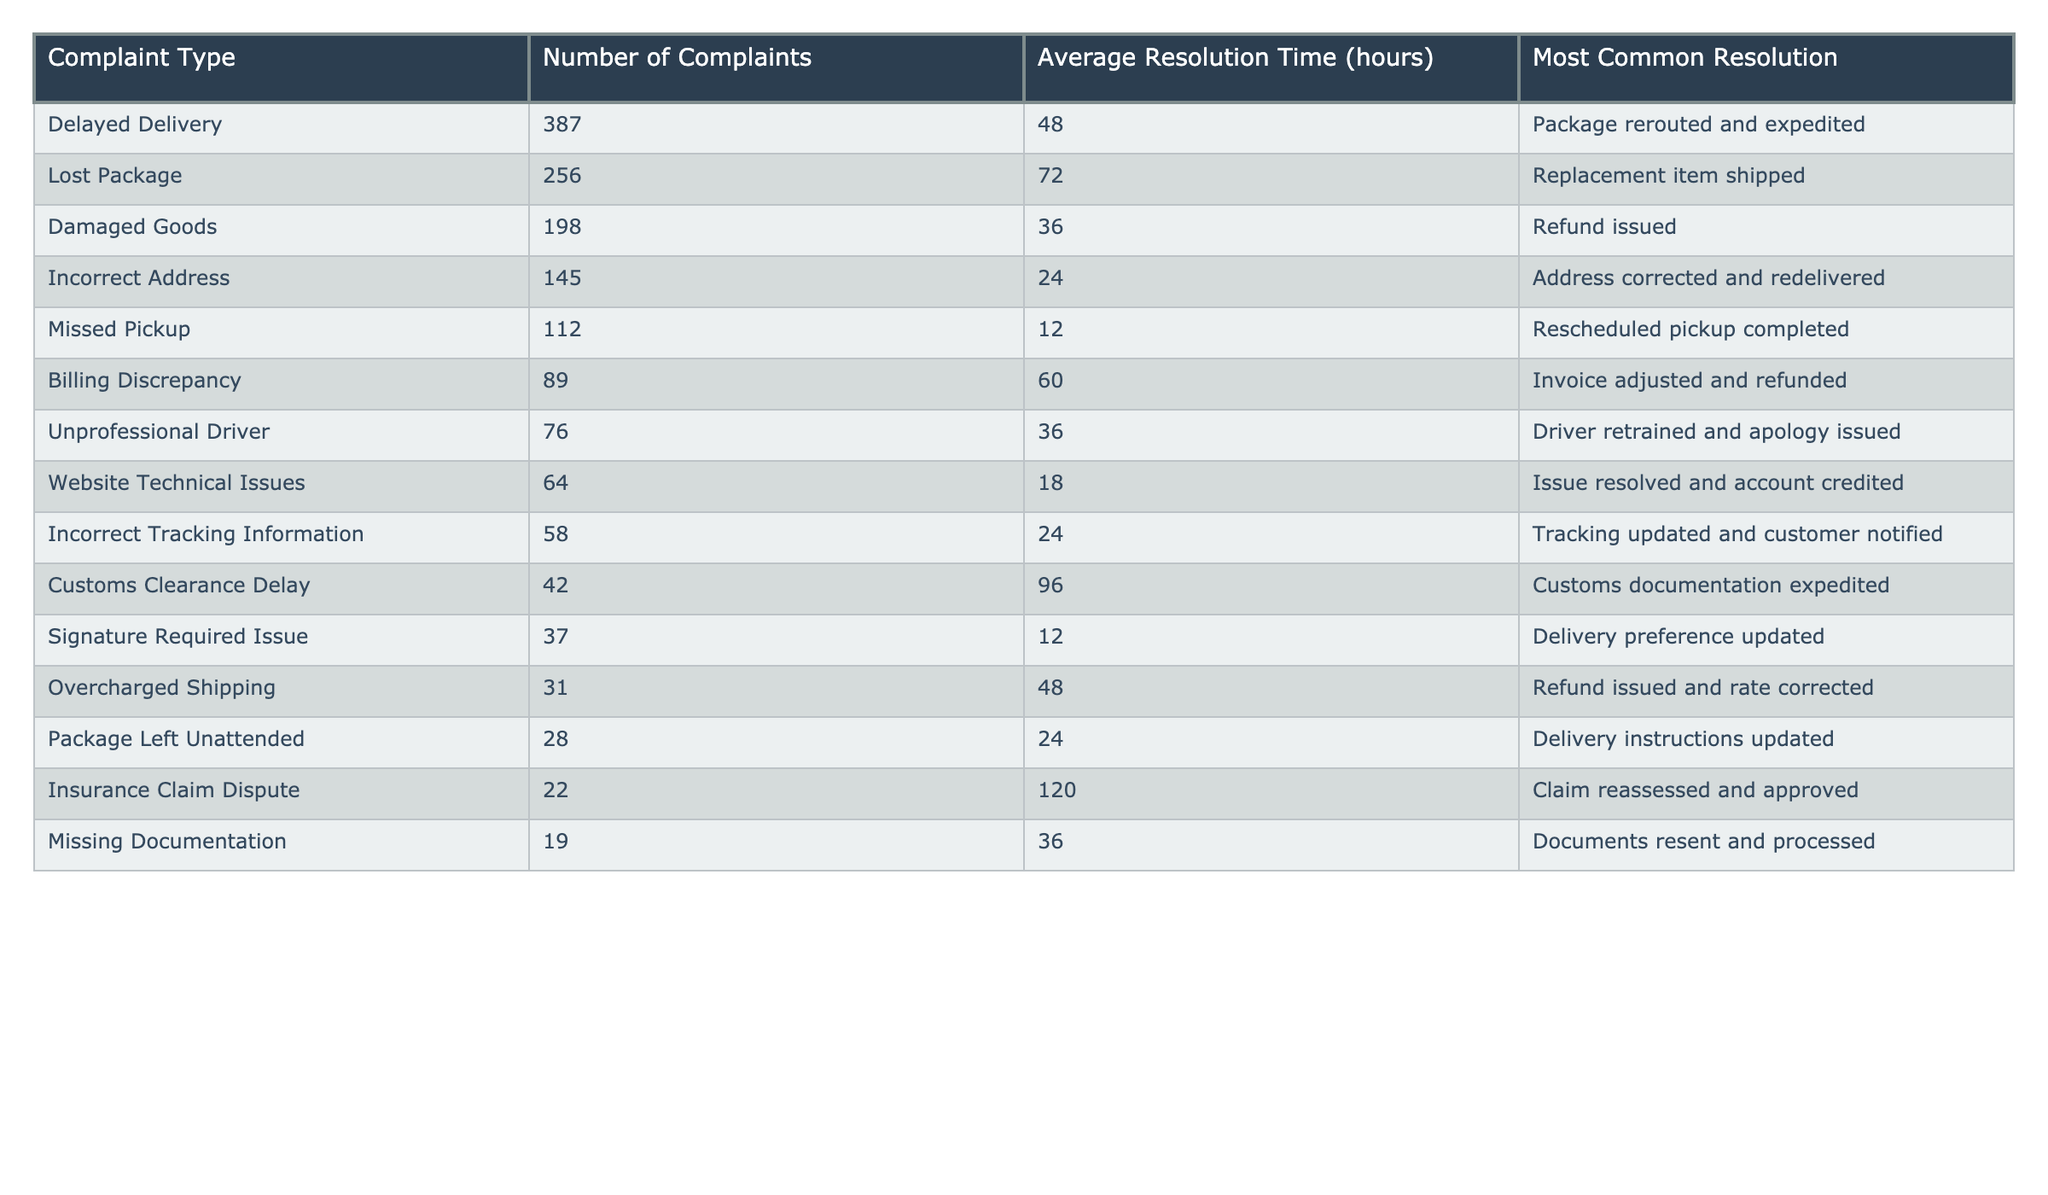What is the most common resolution for "Lost Package" complaints? The table shows that the most common resolution for "Lost Package" complaints is "Replacement item shipped".
Answer: Replacement item shipped How many complaints were filed for "Delayed Delivery"? The table indicates that there were 387 complaints filed for "Delayed Delivery".
Answer: 387 What is the average resolution time for "Damaged Goods"? According to the table, the average resolution time for "Damaged Goods" is 36 hours.
Answer: 36 hours Which complaint type has the highest average resolution time? The table reveals that the complaint type with the highest average resolution time is "Insurance Claim Dispute" with 120 hours.
Answer: Insurance Claim Dispute How many total complaints were recorded across all types? By summing the number of complaints from each type, (387 + 256 + 198 + 145 + 112 + 89 + 76 + 64 + 58 + 42 + 37 + 31 + 28 + 22 + 19) = 1,525, indicating a total of 1,525 complaints recorded.
Answer: 1,525 What percentage of the total complaints were due to "Billing Discrepancy"? To find the percentage, divide the number of "Billing Discrepancy" complaints (89) by the total complaints (1,525) and multiply by 100. (89/1525) * 100 ≈ 5.83%.
Answer: 5.83% Is the average resolution time for "Incorrect Address" longer than that for "Missed Pickup"? The average resolution time for "Incorrect Address" is 24 hours and for "Missed Pickup" it’s 12 hours. Since 24 > 12, the statement is true.
Answer: Yes What is the difference in the number of complaints between "Overcharged Shipping" and "Package Left Unattended"? The number of "Overcharged Shipping" complaints is 31, and for "Package Left Unattended", it's 28. The difference is 31 - 28 = 3.
Answer: 3 What is the average resolution time of all complaint types? To calculate the average, sum all the average resolution times (48 + 72 + 36 + 24 + 12 + 60 + 36 + 18 + 24 + 96 + 12 + 48 + 24 + 120 + 36) = 564, and divide by the number of complaint types (15). Thus, the average resolution time is 564 / 15 = 37.6 hours.
Answer: 37.6 hours Are there more complaints related to delivery issues (like "Delayed Delivery", "Missed Pickup", and "Package Left Unattended") than complaints related to billing issues? The total for delivery issues is (387 + 112 + 28) = 527. For billing issues, it is (89 + 31) = 120. Since 527 > 120, there are more delivery-related complaints.
Answer: Yes 